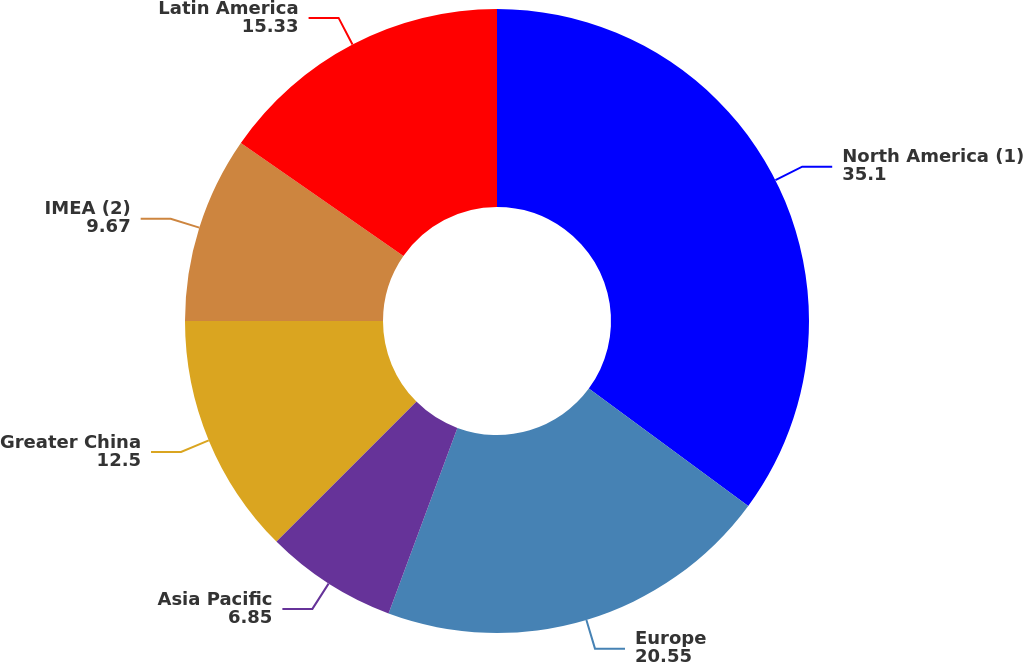Convert chart to OTSL. <chart><loc_0><loc_0><loc_500><loc_500><pie_chart><fcel>North America (1)<fcel>Europe<fcel>Asia Pacific<fcel>Greater China<fcel>IMEA (2)<fcel>Latin America<nl><fcel>35.1%<fcel>20.55%<fcel>6.85%<fcel>12.5%<fcel>9.67%<fcel>15.33%<nl></chart> 